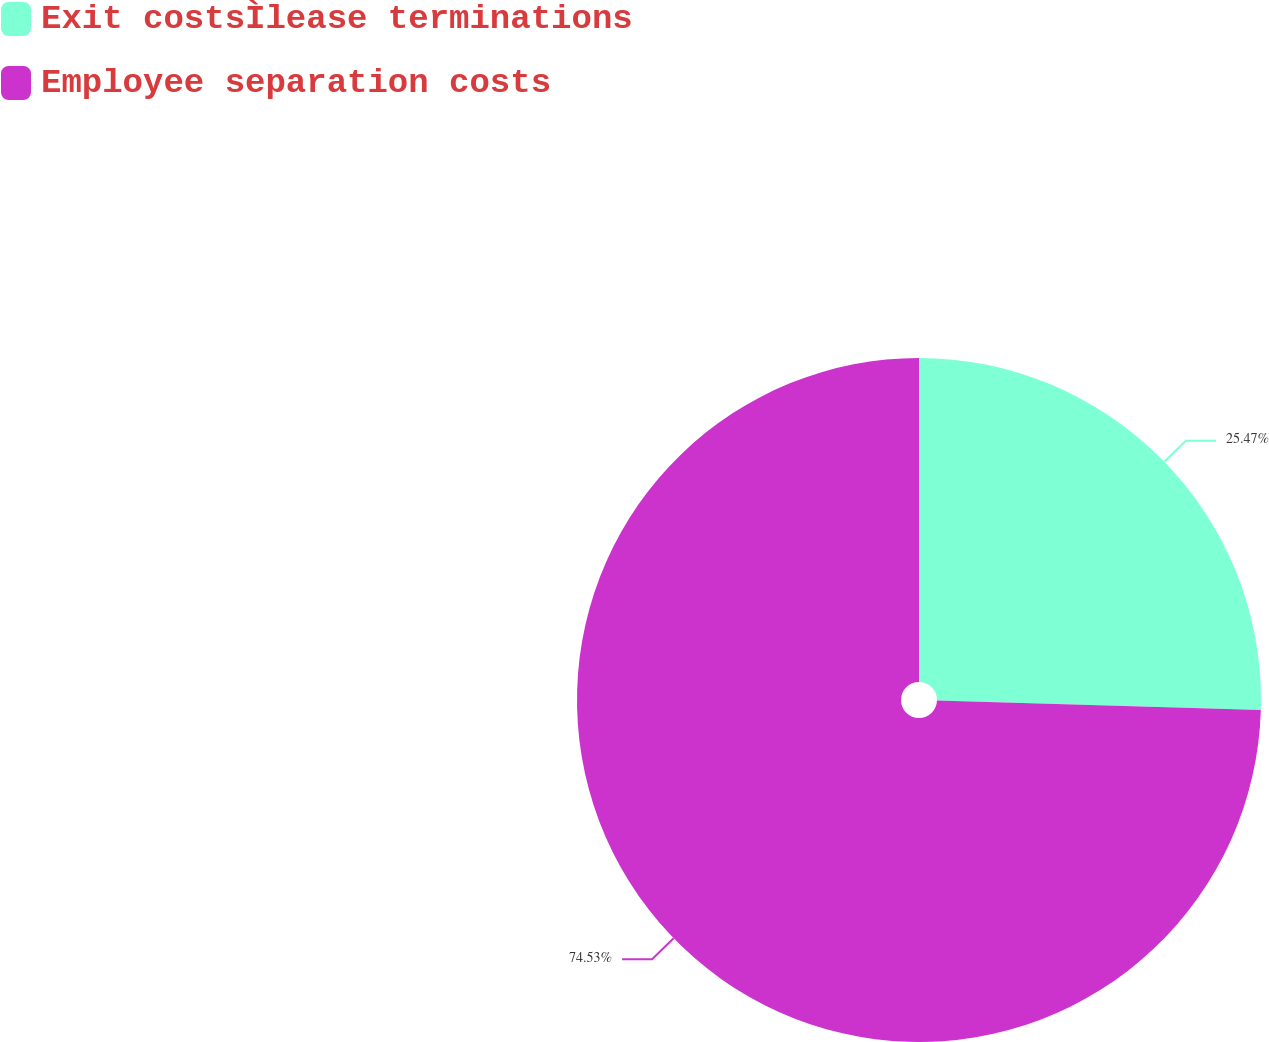<chart> <loc_0><loc_0><loc_500><loc_500><pie_chart><fcel>Exit costsÌlease terminations<fcel>Employee separation costs<nl><fcel>25.47%<fcel>74.53%<nl></chart> 